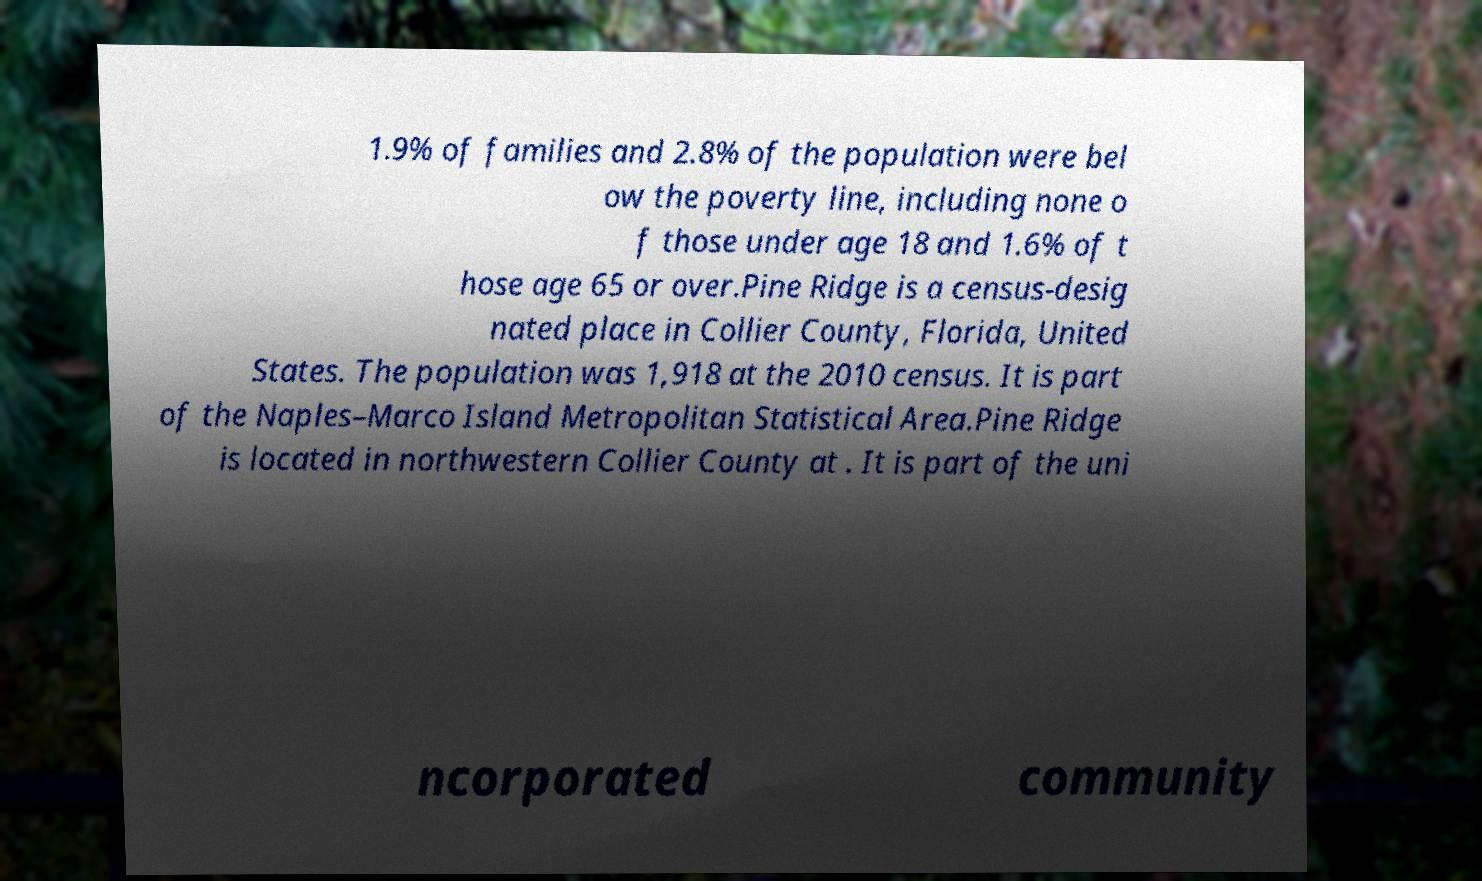Please read and relay the text visible in this image. What does it say? 1.9% of families and 2.8% of the population were bel ow the poverty line, including none o f those under age 18 and 1.6% of t hose age 65 or over.Pine Ridge is a census-desig nated place in Collier County, Florida, United States. The population was 1,918 at the 2010 census. It is part of the Naples–Marco Island Metropolitan Statistical Area.Pine Ridge is located in northwestern Collier County at . It is part of the uni ncorporated community 